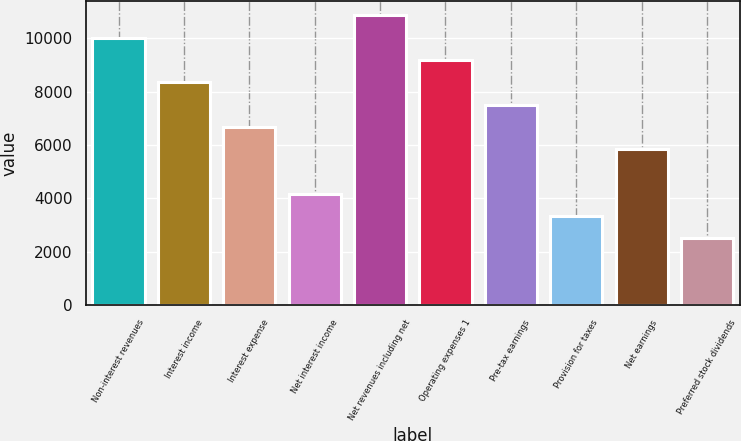<chart> <loc_0><loc_0><loc_500><loc_500><bar_chart><fcel>Non-interest revenues<fcel>Interest income<fcel>Interest expense<fcel>Net interest income<fcel>Net revenues including net<fcel>Operating expenses 1<fcel>Pre-tax earnings<fcel>Provision for taxes<fcel>Net earnings<fcel>Preferred stock dividends<nl><fcel>10021.1<fcel>8350.96<fcel>6680.86<fcel>4175.71<fcel>10856.1<fcel>9186.01<fcel>7515.91<fcel>3340.66<fcel>5845.81<fcel>2505.61<nl></chart> 